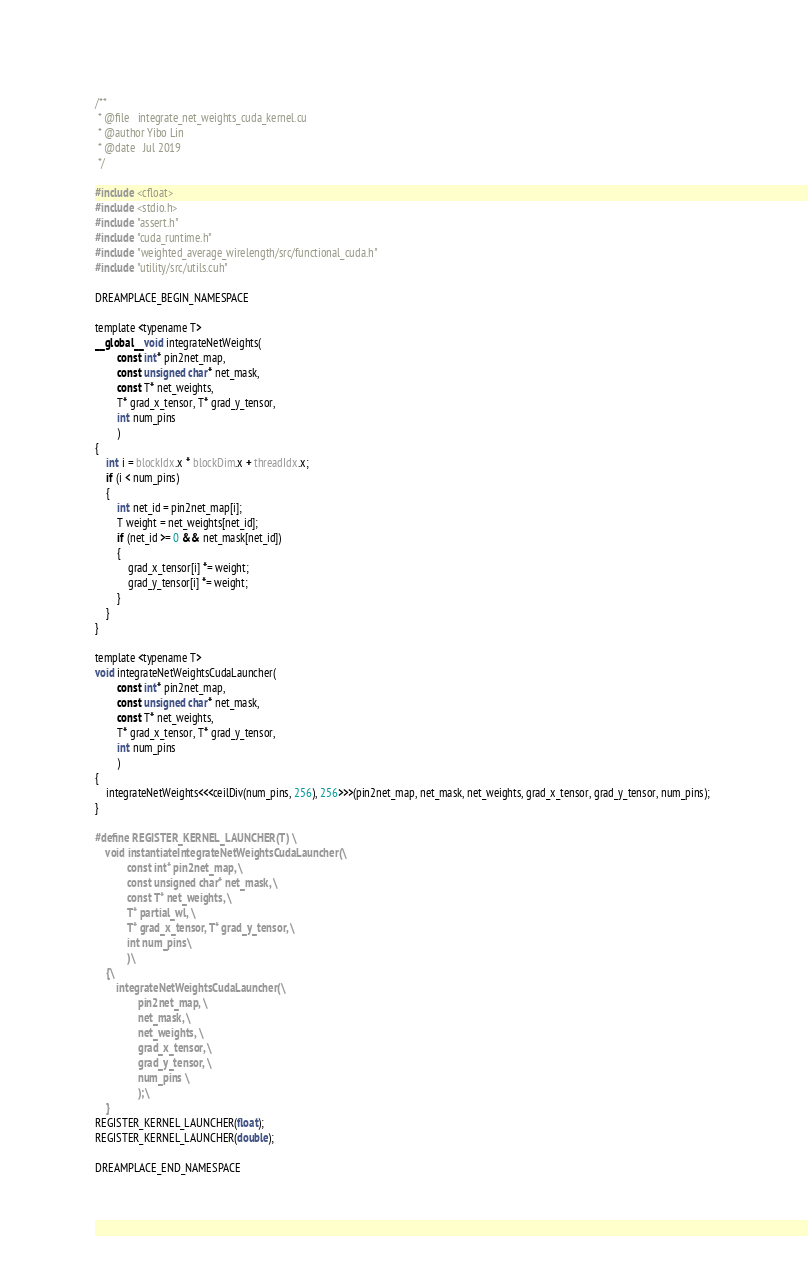Convert code to text. <code><loc_0><loc_0><loc_500><loc_500><_Cuda_>/**
 * @file   integrate_net_weights_cuda_kernel.cu
 * @author Yibo Lin
 * @date   Jul 2019
 */

#include <cfloat>
#include <stdio.h>
#include "assert.h"
#include "cuda_runtime.h"
#include "weighted_average_wirelength/src/functional_cuda.h"
#include "utility/src/utils.cuh"

DREAMPLACE_BEGIN_NAMESPACE

template <typename T>
__global__ void integrateNetWeights(
        const int* pin2net_map, 
        const unsigned char* net_mask, 
        const T* net_weights, 
        T* grad_x_tensor, T* grad_y_tensor, 
        int num_pins
        )
{
    int i = blockIdx.x * blockDim.x + threadIdx.x;
    if (i < num_pins)
    {
        int net_id = pin2net_map[i]; 
        T weight = net_weights[net_id]; 
        if (net_id >= 0 && net_mask[net_id])
        {
            grad_x_tensor[i] *= weight; 
            grad_y_tensor[i] *= weight; 
        }
    }
}

template <typename T>
void integrateNetWeightsCudaLauncher(
        const int* pin2net_map, 
        const unsigned char* net_mask, 
        const T* net_weights, 
        T* grad_x_tensor, T* grad_y_tensor, 
        int num_pins
        )
{
    integrateNetWeights<<<ceilDiv(num_pins, 256), 256>>>(pin2net_map, net_mask, net_weights, grad_x_tensor, grad_y_tensor, num_pins); 
}

#define REGISTER_KERNEL_LAUNCHER(T) \
    void instantiateIntegrateNetWeightsCudaLauncher(\
            const int* pin2net_map, \
            const unsigned char* net_mask, \
            const T* net_weights, \
            T* partial_wl, \
            T* grad_x_tensor, T* grad_y_tensor, \
            int num_pins\
            )\
    {\
        integrateNetWeightsCudaLauncher(\
                pin2net_map, \
                net_mask, \
                net_weights, \
                grad_x_tensor, \
                grad_y_tensor, \
                num_pins \
                );\
    }
REGISTER_KERNEL_LAUNCHER(float);
REGISTER_KERNEL_LAUNCHER(double);

DREAMPLACE_END_NAMESPACE
</code> 